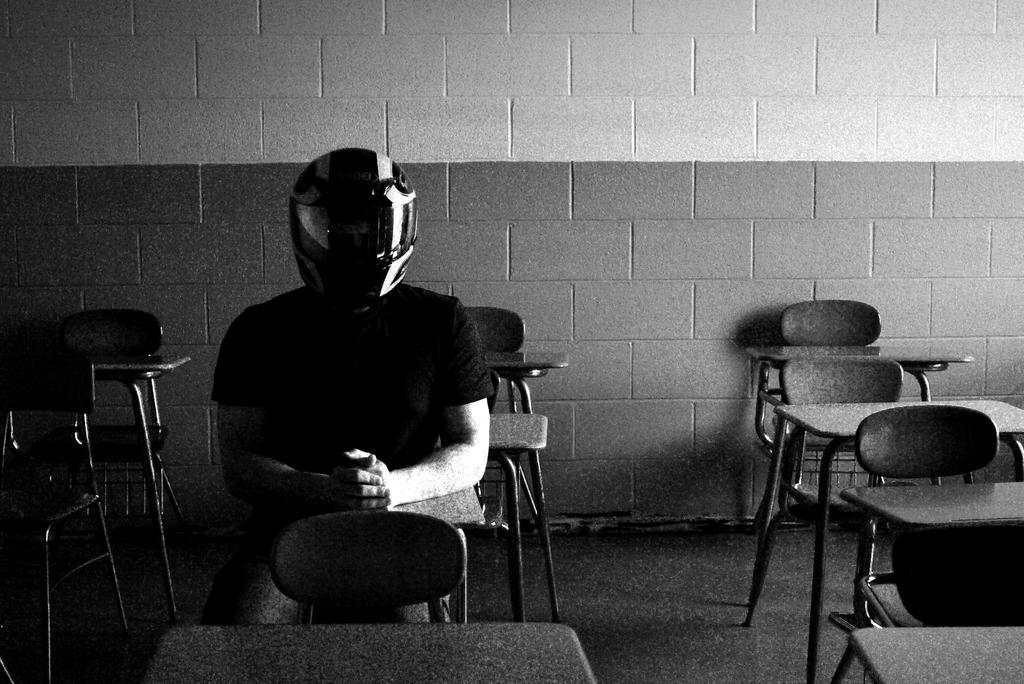Could you give a brief overview of what you see in this image? Here we can see a person sitting on chairs and tables in front of him and he is wearing an helmet 